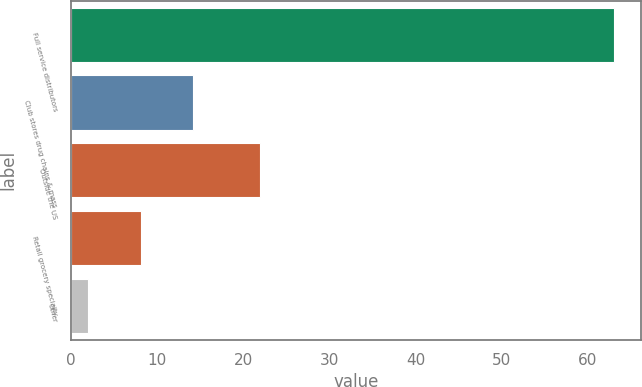<chart> <loc_0><loc_0><loc_500><loc_500><bar_chart><fcel>Full service distributors<fcel>Club stores drug chains & mass<fcel>Outside the US<fcel>Retail grocery specialty<fcel>Other<nl><fcel>63<fcel>14.2<fcel>22<fcel>8.1<fcel>2<nl></chart> 